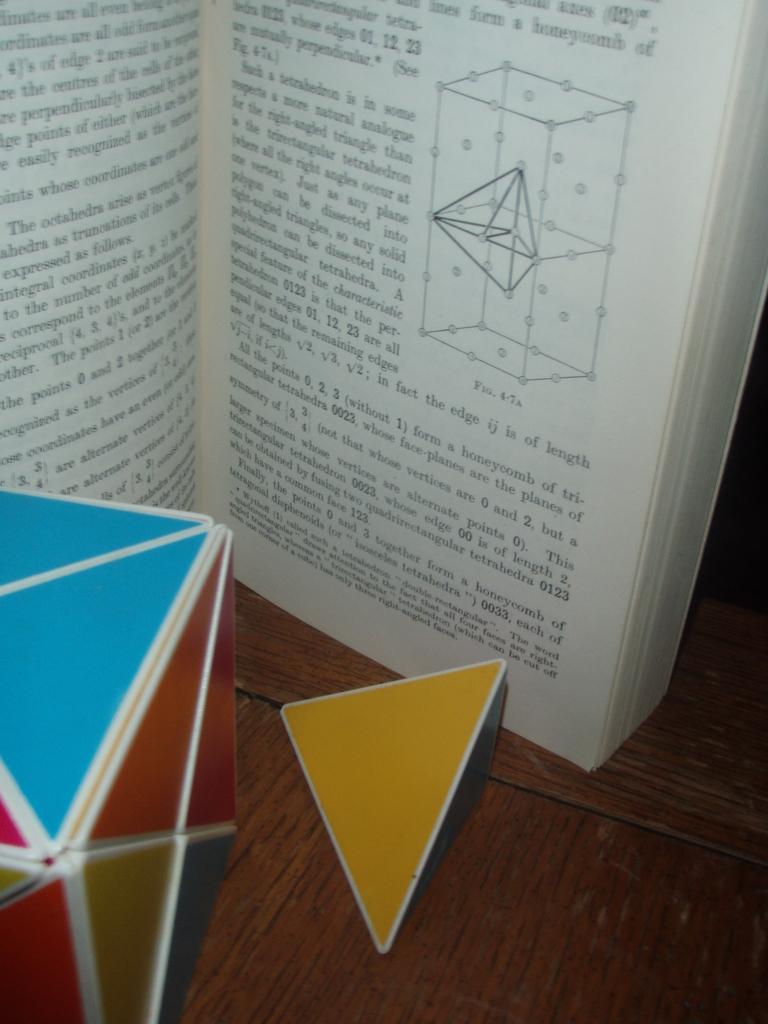Could you give a brief overview of what you see in this image? In this image I can see a book and other objects on a wooden surface. I can also see something written on the book. 